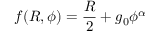<formula> <loc_0><loc_0><loc_500><loc_500>f ( R , \phi ) = \frac { R } { 2 } + g _ { 0 } \phi ^ { \alpha }</formula> 